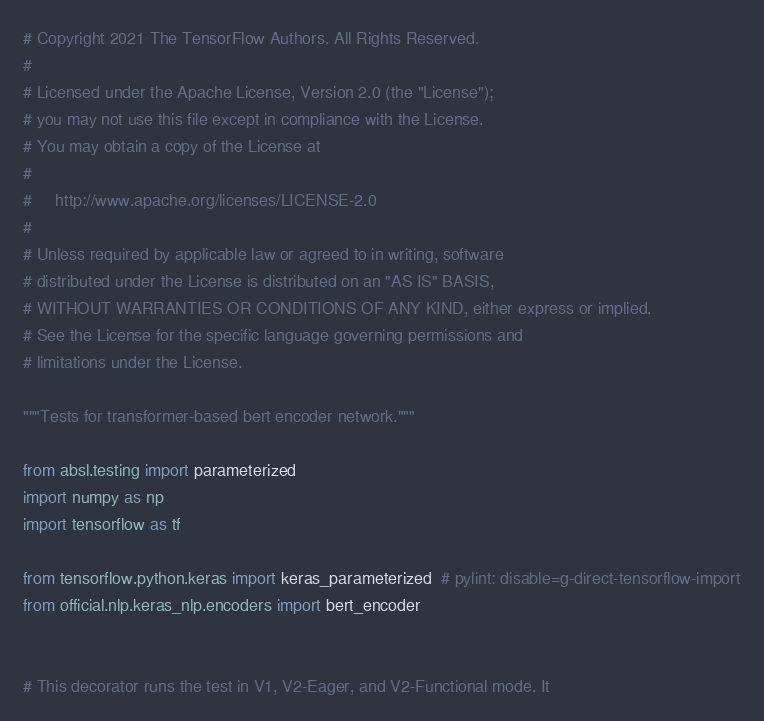Convert code to text. <code><loc_0><loc_0><loc_500><loc_500><_Python_># Copyright 2021 The TensorFlow Authors. All Rights Reserved.
#
# Licensed under the Apache License, Version 2.0 (the "License");
# you may not use this file except in compliance with the License.
# You may obtain a copy of the License at
#
#     http://www.apache.org/licenses/LICENSE-2.0
#
# Unless required by applicable law or agreed to in writing, software
# distributed under the License is distributed on an "AS IS" BASIS,
# WITHOUT WARRANTIES OR CONDITIONS OF ANY KIND, either express or implied.
# See the License for the specific language governing permissions and
# limitations under the License.

"""Tests for transformer-based bert encoder network."""

from absl.testing import parameterized
import numpy as np
import tensorflow as tf

from tensorflow.python.keras import keras_parameterized  # pylint: disable=g-direct-tensorflow-import
from official.nlp.keras_nlp.encoders import bert_encoder


# This decorator runs the test in V1, V2-Eager, and V2-Functional mode. It</code> 